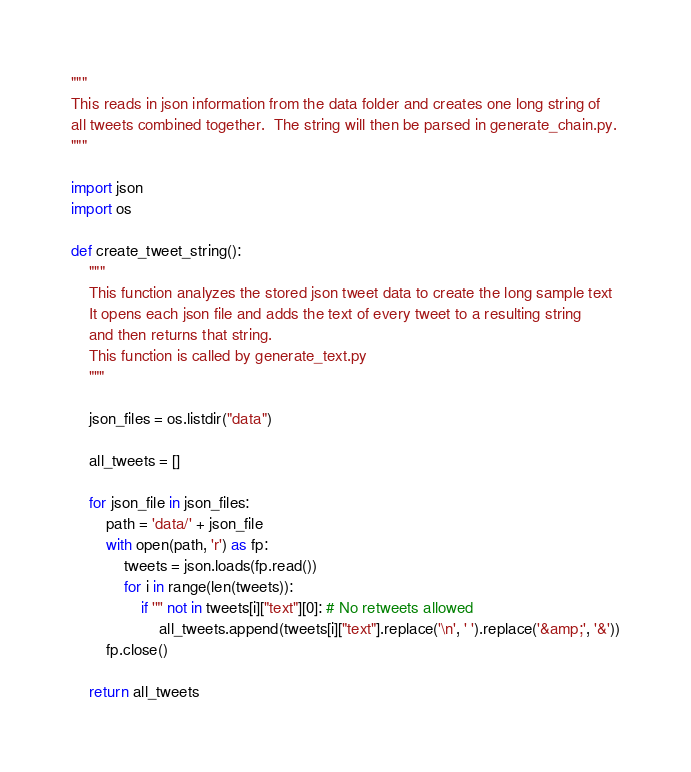Convert code to text. <code><loc_0><loc_0><loc_500><loc_500><_Python_>"""
This reads in json information from the data folder and creates one long string of
all tweets combined together.  The string will then be parsed in generate_chain.py.
"""

import json
import os

def create_tweet_string():
	"""
	This function analyzes the stored json tweet data to create the long sample text
	It opens each json file and adds the text of every tweet to a resulting string
	and then returns that string.
	This function is called by generate_text.py
	"""

	json_files = os.listdir("data")

	all_tweets = []

	for json_file in json_files:
		path = 'data/' + json_file
		with open(path, 'r') as fp:
			tweets = json.loads(fp.read())
			for i in range(len(tweets)):
				if '"' not in tweets[i]["text"][0]: # No retweets allowed
					all_tweets.append(tweets[i]["text"].replace('\n', ' ').replace('&amp;', '&'))
		fp.close()

	return all_tweets
</code> 